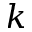Convert formula to latex. <formula><loc_0><loc_0><loc_500><loc_500>k</formula> 